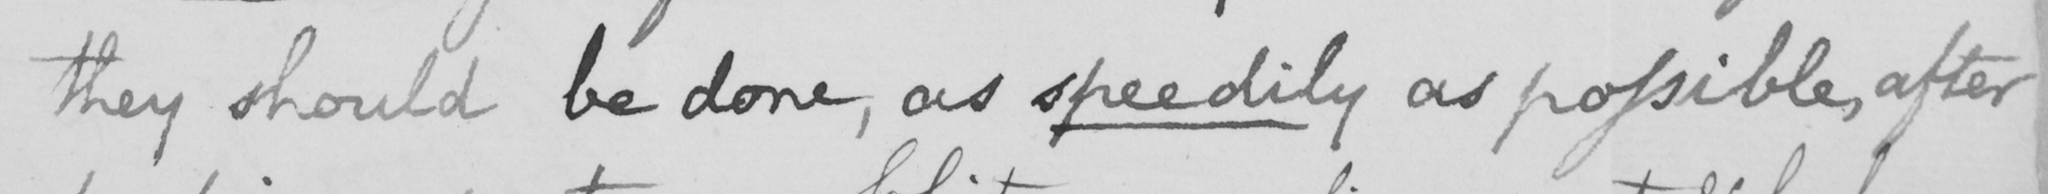What is written in this line of handwriting? they should be done, as speedily as possible, after 